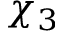Convert formula to latex. <formula><loc_0><loc_0><loc_500><loc_500>\chi _ { 3 }</formula> 